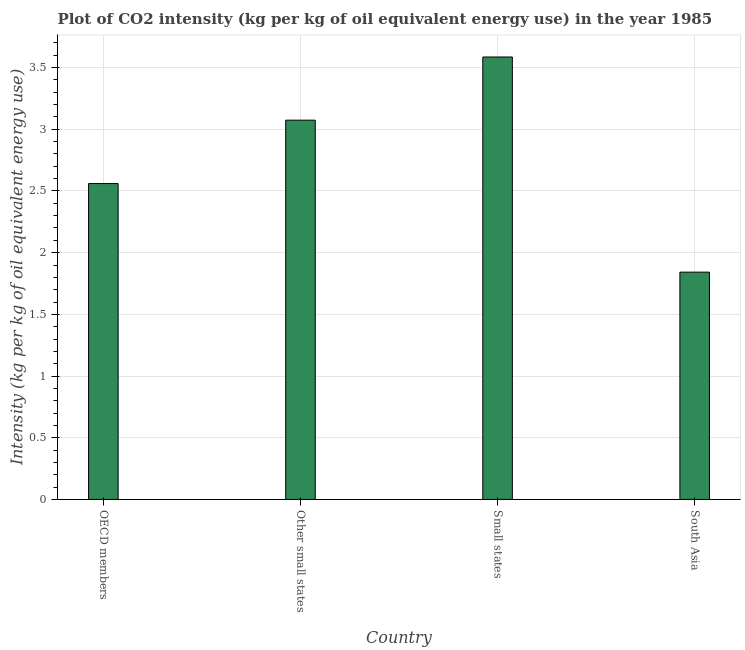Does the graph contain any zero values?
Offer a very short reply. No. Does the graph contain grids?
Your response must be concise. Yes. What is the title of the graph?
Make the answer very short. Plot of CO2 intensity (kg per kg of oil equivalent energy use) in the year 1985. What is the label or title of the Y-axis?
Provide a succinct answer. Intensity (kg per kg of oil equivalent energy use). What is the co2 intensity in Small states?
Your answer should be very brief. 3.59. Across all countries, what is the maximum co2 intensity?
Your answer should be very brief. 3.59. Across all countries, what is the minimum co2 intensity?
Provide a succinct answer. 1.84. In which country was the co2 intensity maximum?
Provide a succinct answer. Small states. In which country was the co2 intensity minimum?
Ensure brevity in your answer.  South Asia. What is the sum of the co2 intensity?
Give a very brief answer. 11.06. What is the difference between the co2 intensity in OECD members and Small states?
Provide a succinct answer. -1.03. What is the average co2 intensity per country?
Make the answer very short. 2.77. What is the median co2 intensity?
Your answer should be compact. 2.82. In how many countries, is the co2 intensity greater than 1.1 kg?
Keep it short and to the point. 4. What is the ratio of the co2 intensity in OECD members to that in South Asia?
Your answer should be very brief. 1.39. Is the difference between the co2 intensity in OECD members and South Asia greater than the difference between any two countries?
Provide a succinct answer. No. What is the difference between the highest and the second highest co2 intensity?
Provide a short and direct response. 0.51. Is the sum of the co2 intensity in Small states and South Asia greater than the maximum co2 intensity across all countries?
Your response must be concise. Yes. What is the difference between the highest and the lowest co2 intensity?
Offer a very short reply. 1.74. In how many countries, is the co2 intensity greater than the average co2 intensity taken over all countries?
Provide a succinct answer. 2. How many countries are there in the graph?
Make the answer very short. 4. Are the values on the major ticks of Y-axis written in scientific E-notation?
Your response must be concise. No. What is the Intensity (kg per kg of oil equivalent energy use) of OECD members?
Your answer should be compact. 2.56. What is the Intensity (kg per kg of oil equivalent energy use) in Other small states?
Give a very brief answer. 3.07. What is the Intensity (kg per kg of oil equivalent energy use) in Small states?
Keep it short and to the point. 3.59. What is the Intensity (kg per kg of oil equivalent energy use) in South Asia?
Your response must be concise. 1.84. What is the difference between the Intensity (kg per kg of oil equivalent energy use) in OECD members and Other small states?
Make the answer very short. -0.51. What is the difference between the Intensity (kg per kg of oil equivalent energy use) in OECD members and Small states?
Provide a succinct answer. -1.03. What is the difference between the Intensity (kg per kg of oil equivalent energy use) in OECD members and South Asia?
Your answer should be compact. 0.72. What is the difference between the Intensity (kg per kg of oil equivalent energy use) in Other small states and Small states?
Keep it short and to the point. -0.51. What is the difference between the Intensity (kg per kg of oil equivalent energy use) in Other small states and South Asia?
Give a very brief answer. 1.23. What is the difference between the Intensity (kg per kg of oil equivalent energy use) in Small states and South Asia?
Provide a short and direct response. 1.74. What is the ratio of the Intensity (kg per kg of oil equivalent energy use) in OECD members to that in Other small states?
Provide a short and direct response. 0.83. What is the ratio of the Intensity (kg per kg of oil equivalent energy use) in OECD members to that in Small states?
Your response must be concise. 0.71. What is the ratio of the Intensity (kg per kg of oil equivalent energy use) in OECD members to that in South Asia?
Make the answer very short. 1.39. What is the ratio of the Intensity (kg per kg of oil equivalent energy use) in Other small states to that in Small states?
Provide a short and direct response. 0.86. What is the ratio of the Intensity (kg per kg of oil equivalent energy use) in Other small states to that in South Asia?
Your response must be concise. 1.67. What is the ratio of the Intensity (kg per kg of oil equivalent energy use) in Small states to that in South Asia?
Provide a short and direct response. 1.95. 